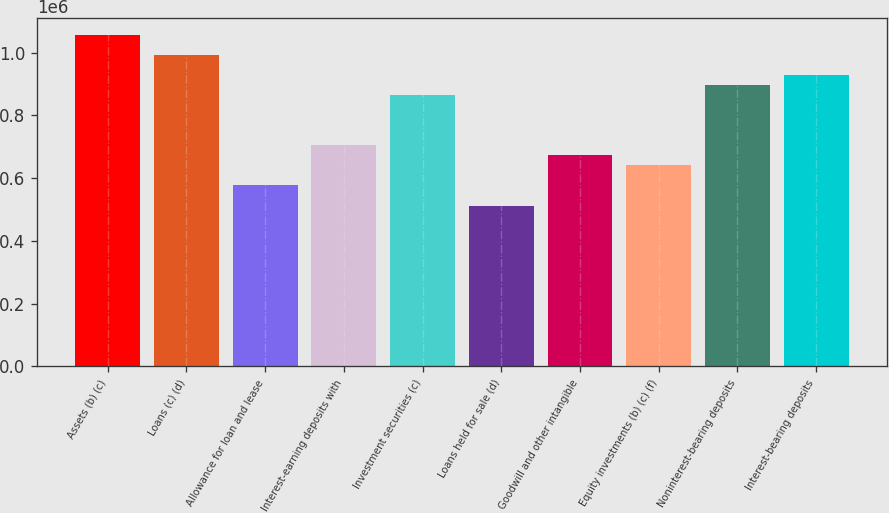Convert chart to OTSL. <chart><loc_0><loc_0><loc_500><loc_500><bar_chart><fcel>Assets (b) (c)<fcel>Loans (c) (d)<fcel>Allowance for loan and lease<fcel>Interest-earning deposits with<fcel>Investment securities (c)<fcel>Loans held for sale (d)<fcel>Goodwill and other intangible<fcel>Equity investments (b) (c) (f)<fcel>Noninterest-bearing deposits<fcel>Interest-bearing deposits<nl><fcel>1.05663e+06<fcel>992592<fcel>576344<fcel>704421<fcel>864516<fcel>512306<fcel>672402<fcel>640383<fcel>896535<fcel>928554<nl></chart> 